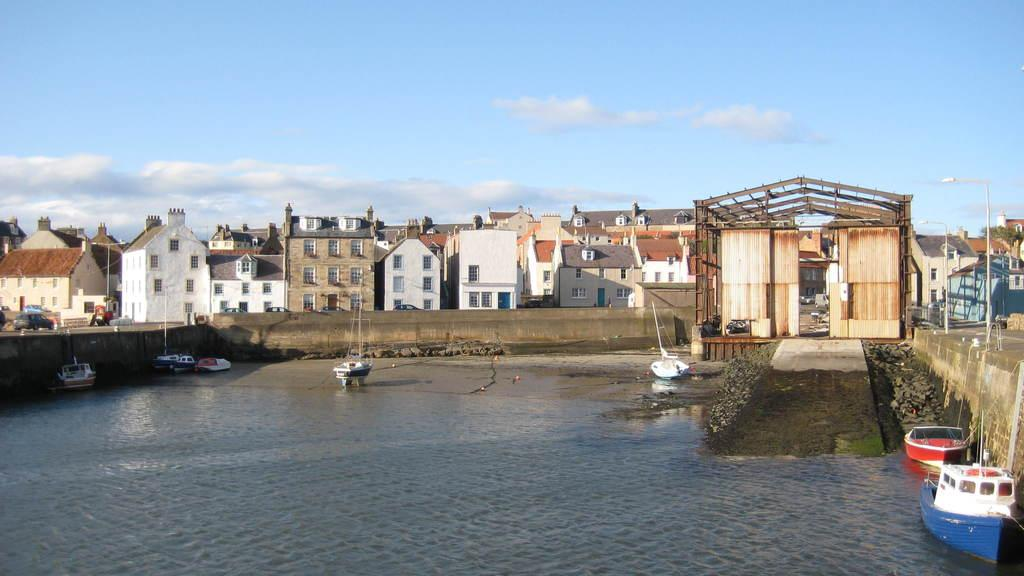What is present on the river in the image? There are boats on the river in the image. What can be seen in the distance behind the boats? There are buildings in the background of the image. What is on the road in front of the buildings? There are vehicles on the road in front of the buildings. What structures are visible in the image besides the buildings? There are poles visible in the image. What is visible above the buildings and poles? The sky is visible in the image. What type of pan is being used to cook food on the river in the image? There is no pan or cooking activity present in the image; it features boats on a river with buildings and vehicles in the background. What kind of nut is being cracked by the quiver in the image? There is no nut or quiver present in the image. 